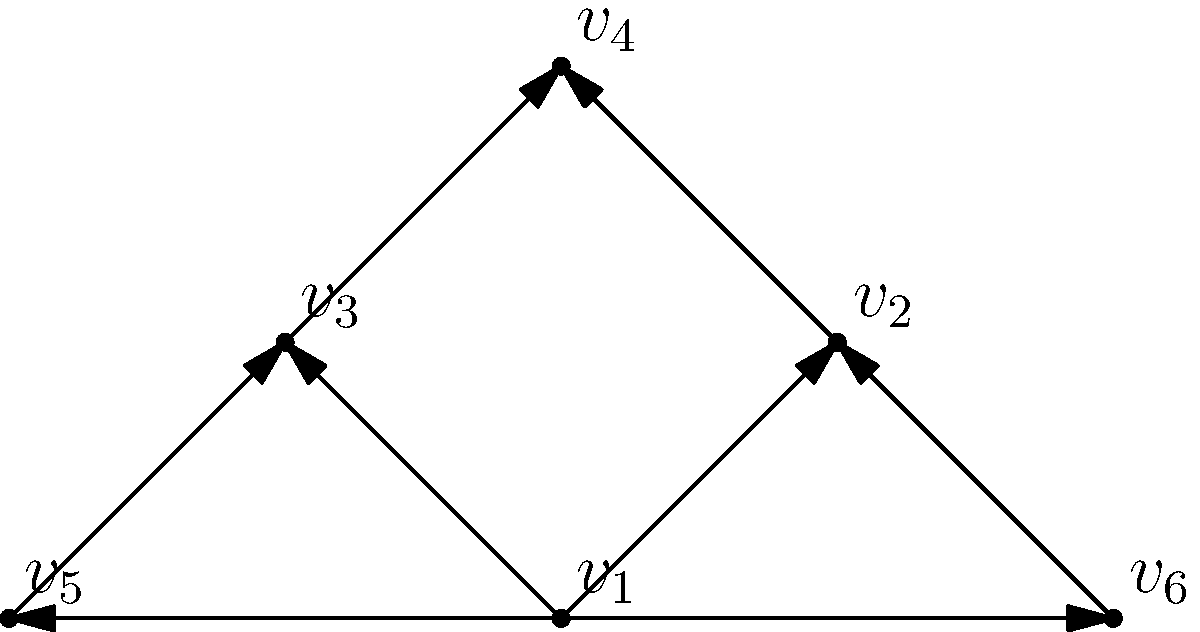In the directed graph representing the flow of power in an ancient Greek democracy, vertex $v_1$ represents the assembly of citizens. If we define the "influence score" of a vertex as the number of vertices it can reach directly or indirectly, what is the influence score of $v_1$? To determine the influence score of $v_1$, we need to count the number of vertices that can be reached from $v_1$ either directly or through a path. Let's analyze this step-by-step:

1. Direct connections from $v_1$:
   - $v_1$ → $v_2$
   - $v_1$ → $v_3$
   - $v_1$ → $v_5$
   - $v_1$ → $v_6$

2. Indirect connections:
   - $v_1$ → $v_2$ → $v_4$
   - $v_1$ → $v_3$ → $v_4$

3. Vertices reached:
   - $v_1$ can reach $v_2$, $v_3$, $v_4$, $v_5$, and $v_6$

4. Count of vertices reached:
   - $v_1$ can reach 5 other vertices

5. Including $v_1$ itself:
   - The total count is 5 + 1 = 6

Therefore, the influence score of $v_1$ is 6, as it can influence all vertices in the graph, including itself.
Answer: 6 